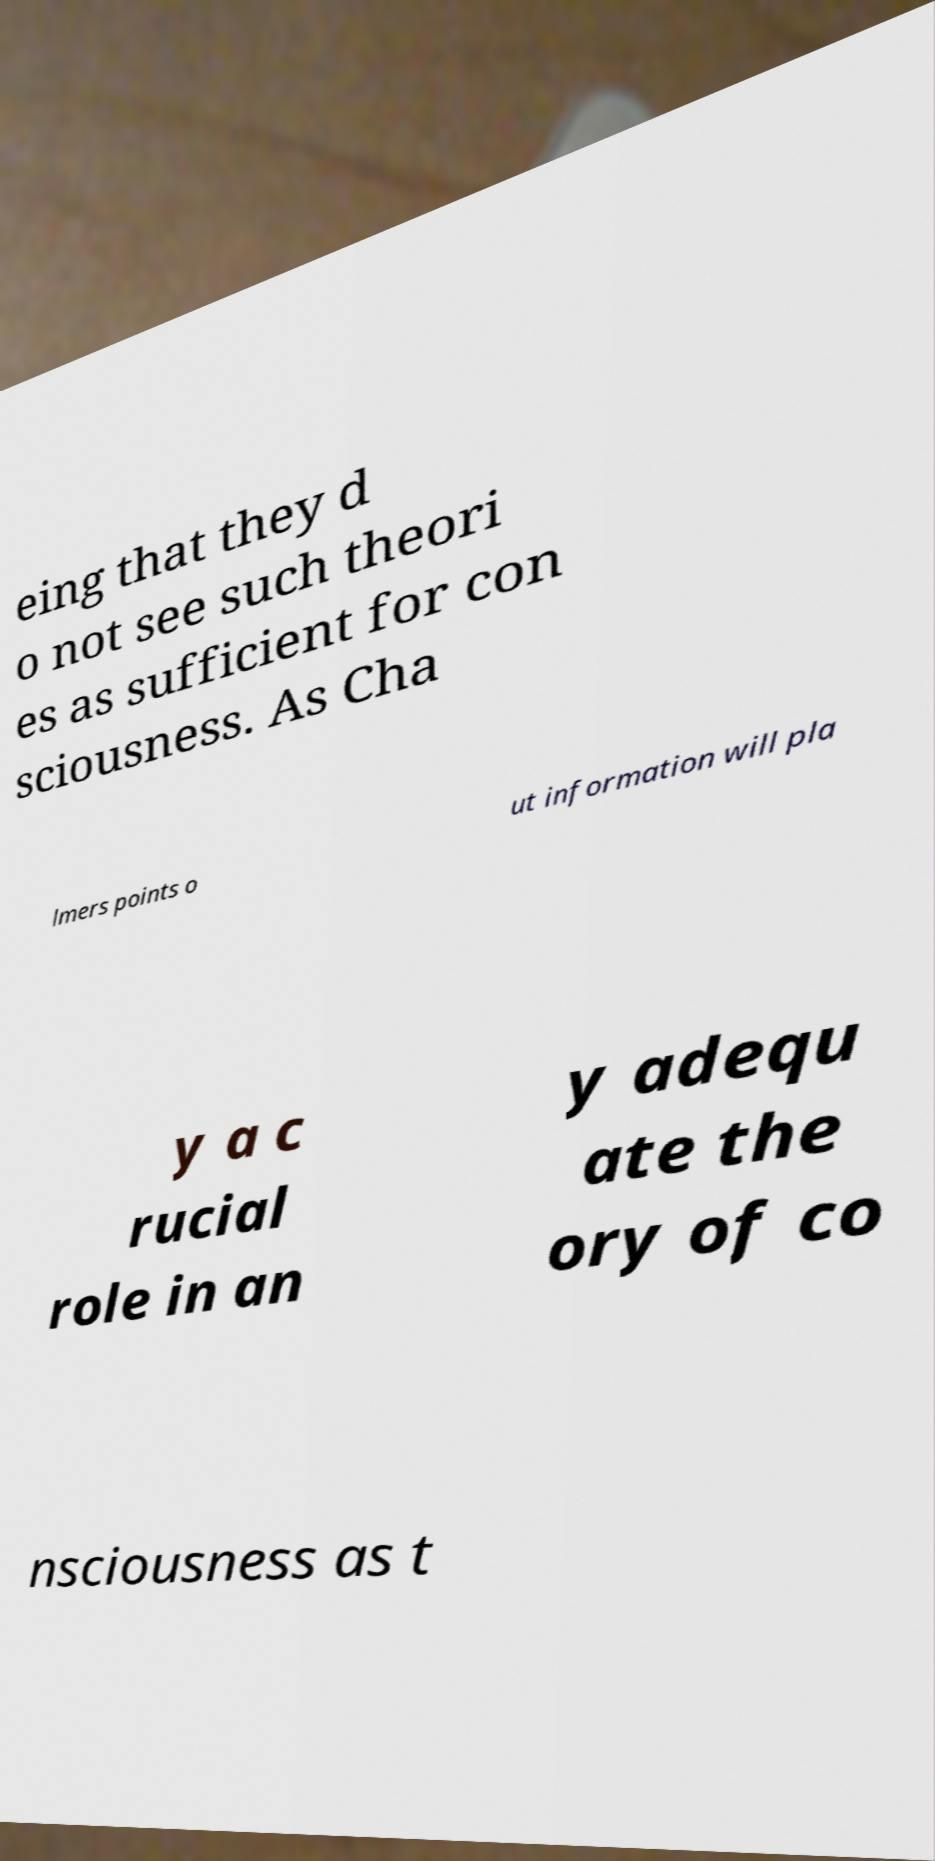Please identify and transcribe the text found in this image. eing that they d o not see such theori es as sufficient for con sciousness. As Cha lmers points o ut information will pla y a c rucial role in an y adequ ate the ory of co nsciousness as t 